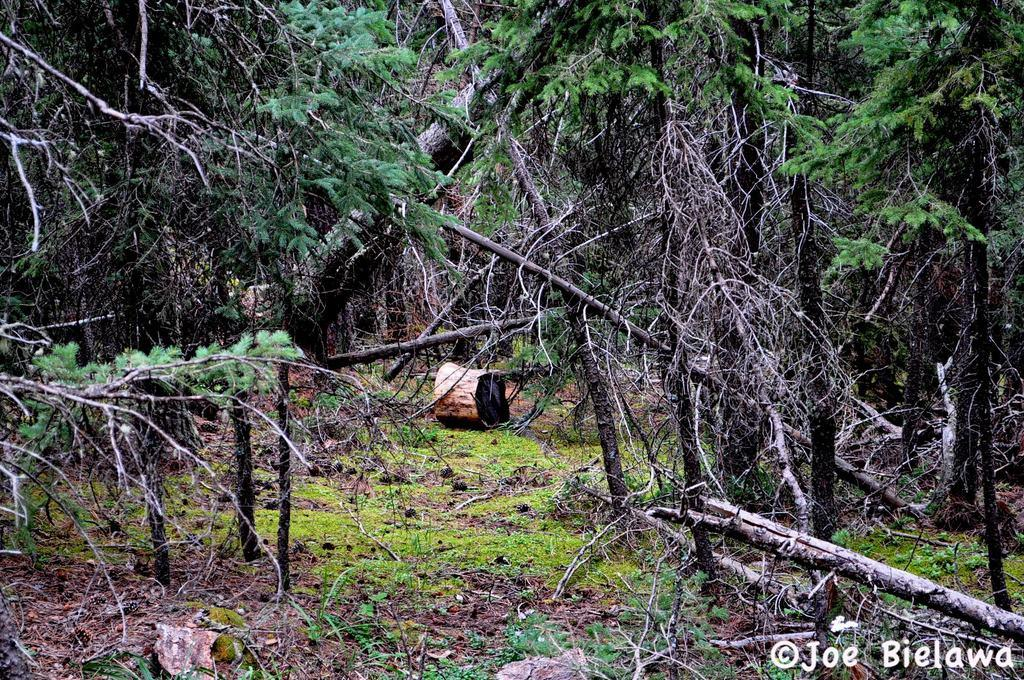What is the main object on the ground in the image? There is an object on the ground in the image, but the specific object is not mentioned in the facts. What is the color and texture of the ground in the image? The ground is green and appears to be grassy. What can be seen around the object on the ground? There are trees around the object. Where is the text or writing located in the image? The text or writing is in the right bottom corner of the image. How many ears of corn are visible in the image? There is no corn present in the image. What type of knot is being used to secure the object on the ground? There is no knot visible in the image, as the object on the ground is not described in detail. 